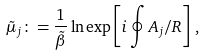<formula> <loc_0><loc_0><loc_500><loc_500>\tilde { \mu } _ { j } \colon = \frac { 1 } { \tilde { \beta } } \ln \exp \left [ i \oint A _ { j } / R \right ] \, ,</formula> 